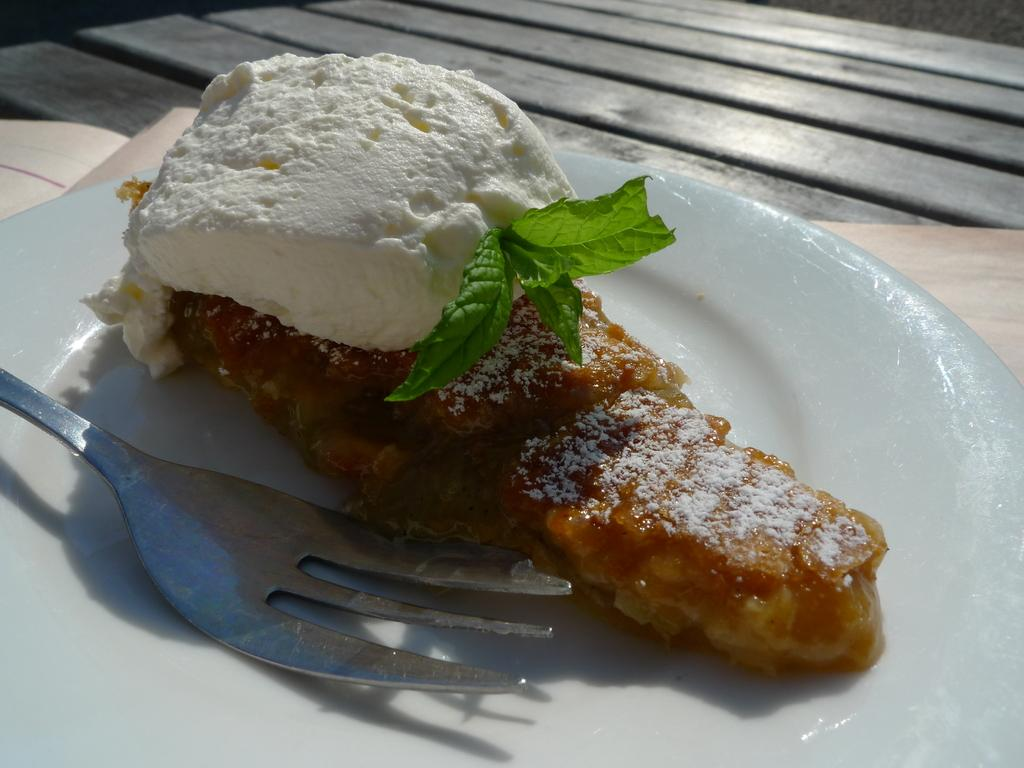What is on the plate in the image? There is a food item on a plate in the image. What utensil is present on the plate? A fork is present on the plate. Can you describe the object in the image? Unfortunately, the facts provided do not give enough information to describe the object in the image. What type of furniture can be seen in the background of the image? There is a wooden table in the background of the image. How many kittens are sitting on the rail in the image? There are no kittens or rails present in the image. What is your opinion on the food item in the image? As an AI, I do not have personal opinions, and the facts provided do not give enough information to form an opinion on the food item. 